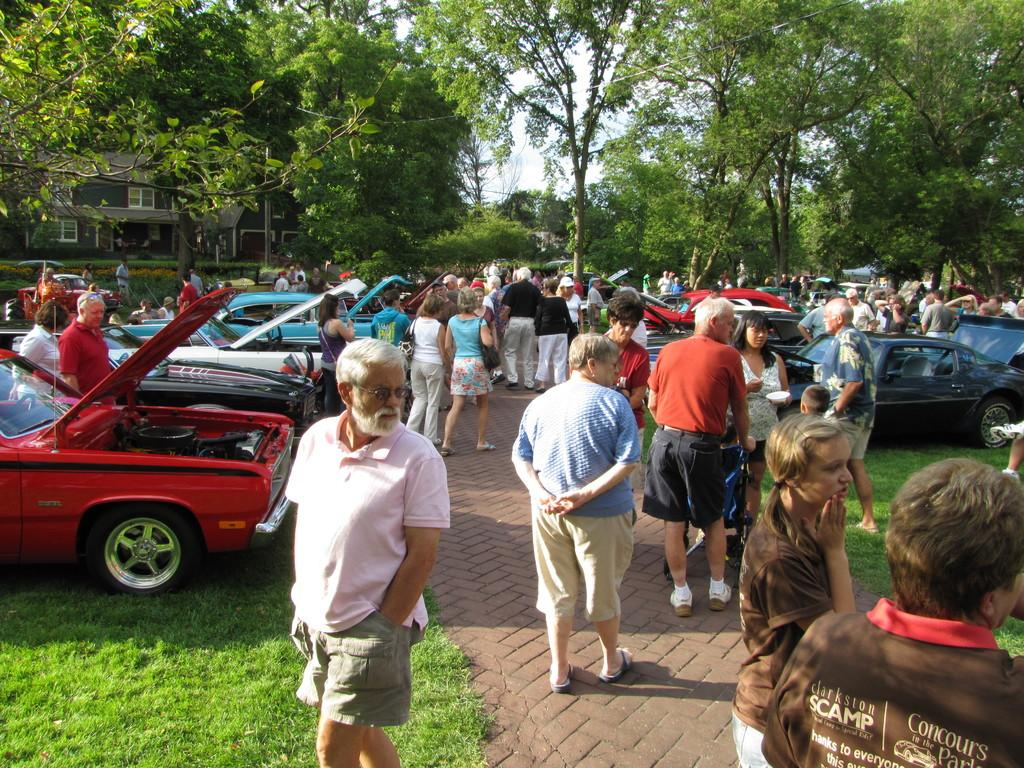How many people are visible in the image? There are many people in the image. What can be seen in the background of the image? There are many cars and trees in the background of the image. What type of structure is present in the image? There is a house in the image. What is the color of the background in the image? The background of the image appears to be white. What type of square is present in the image? There is no square present in the image. Who is the authority figure in the image? There is no specific authority figure mentioned or depicted in the image. 